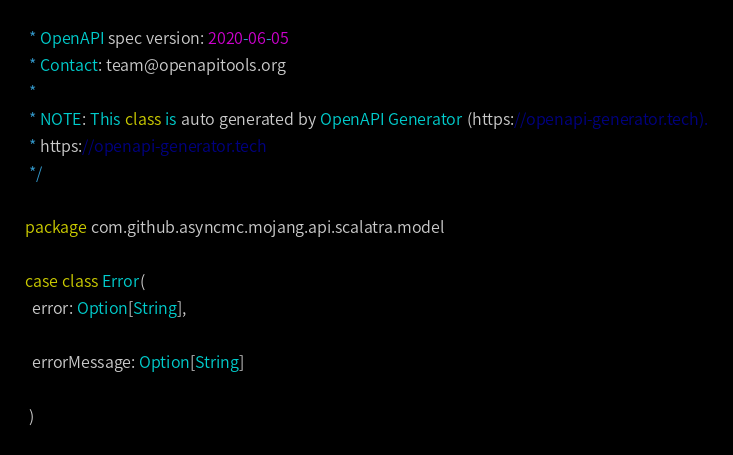Convert code to text. <code><loc_0><loc_0><loc_500><loc_500><_Scala_> * OpenAPI spec version: 2020-06-05
 * Contact: team@openapitools.org
 *
 * NOTE: This class is auto generated by OpenAPI Generator (https://openapi-generator.tech).
 * https://openapi-generator.tech
 */

package com.github.asyncmc.mojang.api.scalatra.model

case class Error(
  error: Option[String],

  errorMessage: Option[String]

 )
</code> 